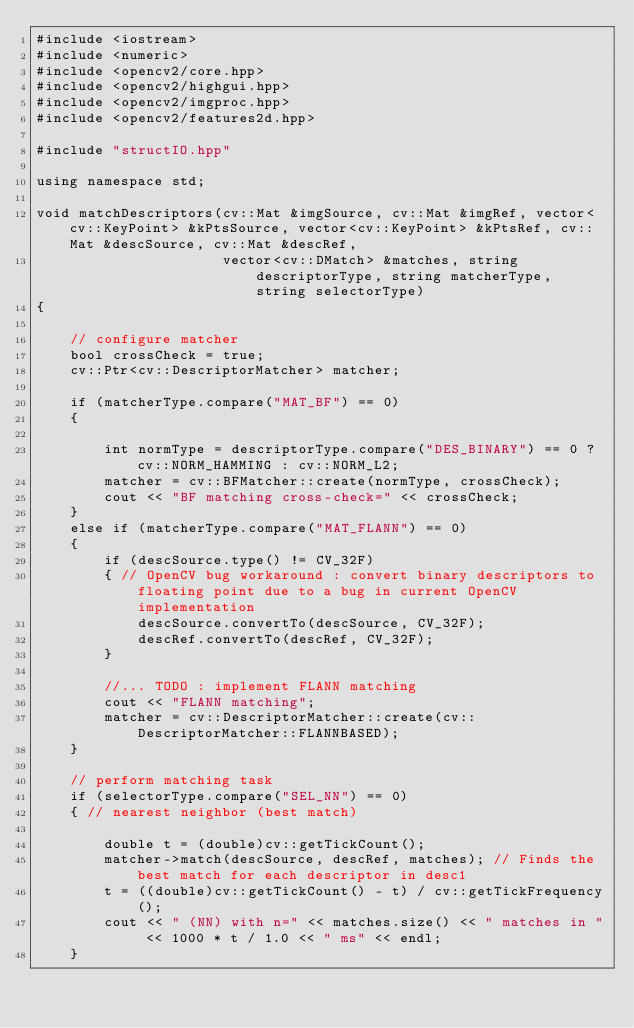Convert code to text. <code><loc_0><loc_0><loc_500><loc_500><_C++_>#include <iostream>
#include <numeric>
#include <opencv2/core.hpp>
#include <opencv2/highgui.hpp>
#include <opencv2/imgproc.hpp>
#include <opencv2/features2d.hpp>

#include "structIO.hpp"

using namespace std;

void matchDescriptors(cv::Mat &imgSource, cv::Mat &imgRef, vector<cv::KeyPoint> &kPtsSource, vector<cv::KeyPoint> &kPtsRef, cv::Mat &descSource, cv::Mat &descRef,
                      vector<cv::DMatch> &matches, string descriptorType, string matcherType, string selectorType)
{

    // configure matcher
    bool crossCheck = true;
    cv::Ptr<cv::DescriptorMatcher> matcher;

    if (matcherType.compare("MAT_BF") == 0)
    {

        int normType = descriptorType.compare("DES_BINARY") == 0 ? cv::NORM_HAMMING : cv::NORM_L2;
        matcher = cv::BFMatcher::create(normType, crossCheck);
        cout << "BF matching cross-check=" << crossCheck;
    }
    else if (matcherType.compare("MAT_FLANN") == 0)
    {
        if (descSource.type() != CV_32F)
        { // OpenCV bug workaround : convert binary descriptors to floating point due to a bug in current OpenCV implementation
            descSource.convertTo(descSource, CV_32F);
            descRef.convertTo(descRef, CV_32F);
        }

        //... TODO : implement FLANN matching
        cout << "FLANN matching";
        matcher = cv::DescriptorMatcher::create(cv::DescriptorMatcher::FLANNBASED);
    }

    // perform matching task
    if (selectorType.compare("SEL_NN") == 0)
    { // nearest neighbor (best match)

        double t = (double)cv::getTickCount();
        matcher->match(descSource, descRef, matches); // Finds the best match for each descriptor in desc1
        t = ((double)cv::getTickCount() - t) / cv::getTickFrequency();
        cout << " (NN) with n=" << matches.size() << " matches in " << 1000 * t / 1.0 << " ms" << endl;
    }</code> 